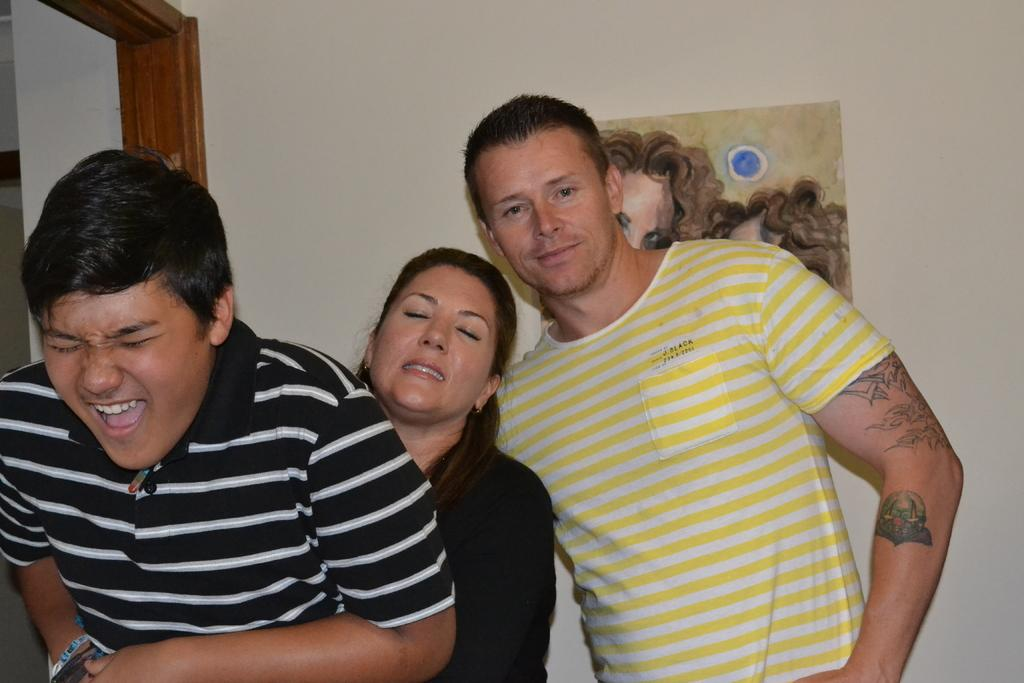How many people are present in the image? There are three persons standing in the image. What can be seen in the background of the image? There is a wall and a door in the background of the image. Is there any artwork visible in the image? Yes, there is a painting on the wall in the image. What type of dress is the crow wearing in the image? There is no crow present in the image, and therefore no dress or any other clothing item can be attributed to it. 